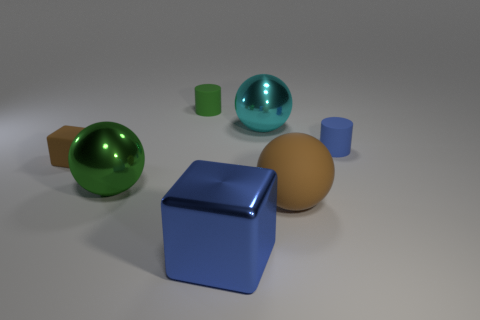Add 2 big green metallic objects. How many objects exist? 9 Subtract all cylinders. How many objects are left? 5 Add 2 big balls. How many big balls are left? 5 Add 5 tiny brown rubber blocks. How many tiny brown rubber blocks exist? 6 Subtract 0 brown cylinders. How many objects are left? 7 Subtract all tiny gray things. Subtract all large cyan shiny things. How many objects are left? 6 